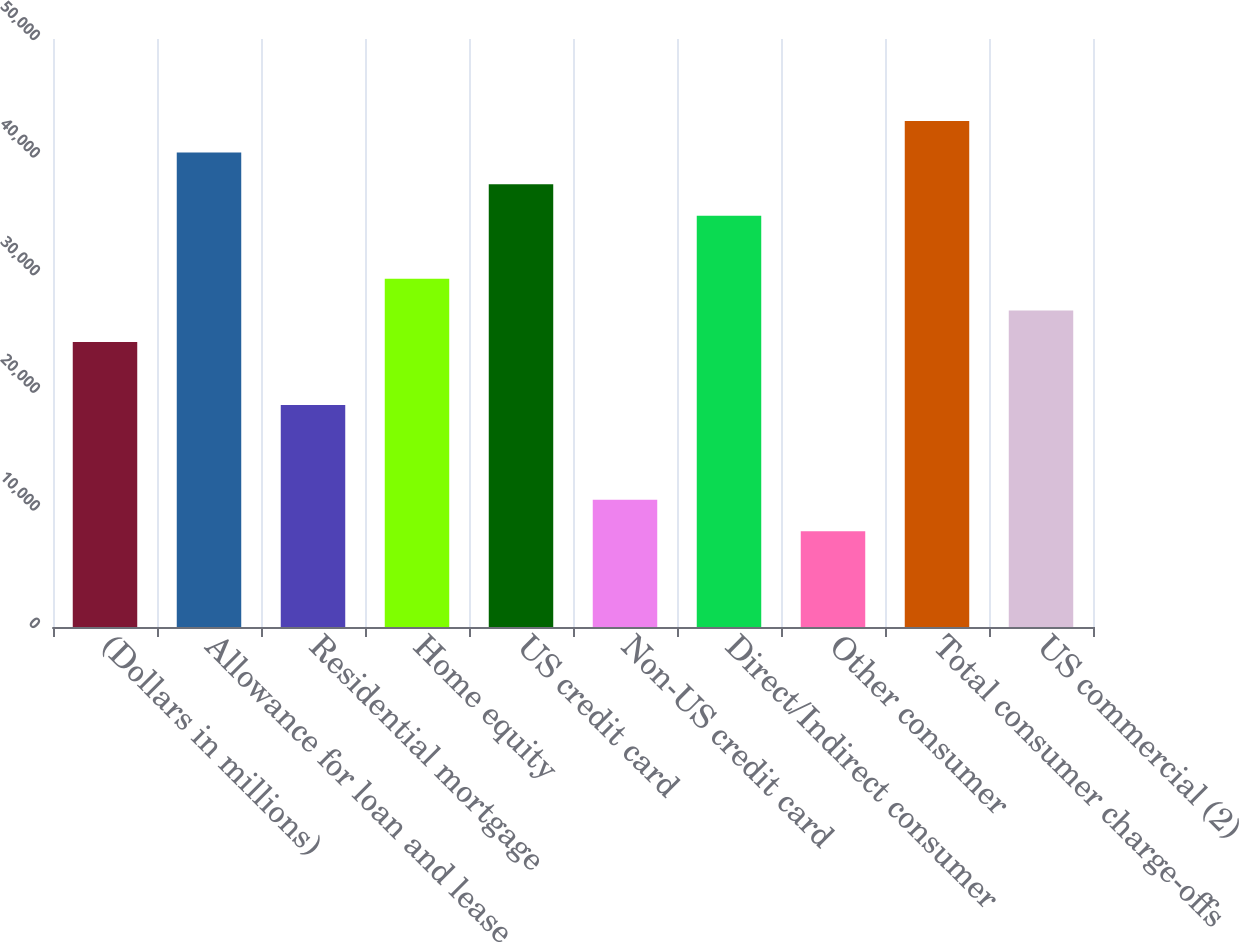Convert chart to OTSL. <chart><loc_0><loc_0><loc_500><loc_500><bar_chart><fcel>(Dollars in millions)<fcel>Allowance for loan and lease<fcel>Residential mortgage<fcel>Home equity<fcel>US credit card<fcel>Non-US credit card<fcel>Direct/Indirect consumer<fcel>Other consumer<fcel>Total consumer charge-offs<fcel>US commercial (2)<nl><fcel>24237.7<fcel>40343.5<fcel>18869.1<fcel>29606.3<fcel>37659.2<fcel>10816.2<fcel>34974.9<fcel>8131.9<fcel>43027.8<fcel>26922<nl></chart> 